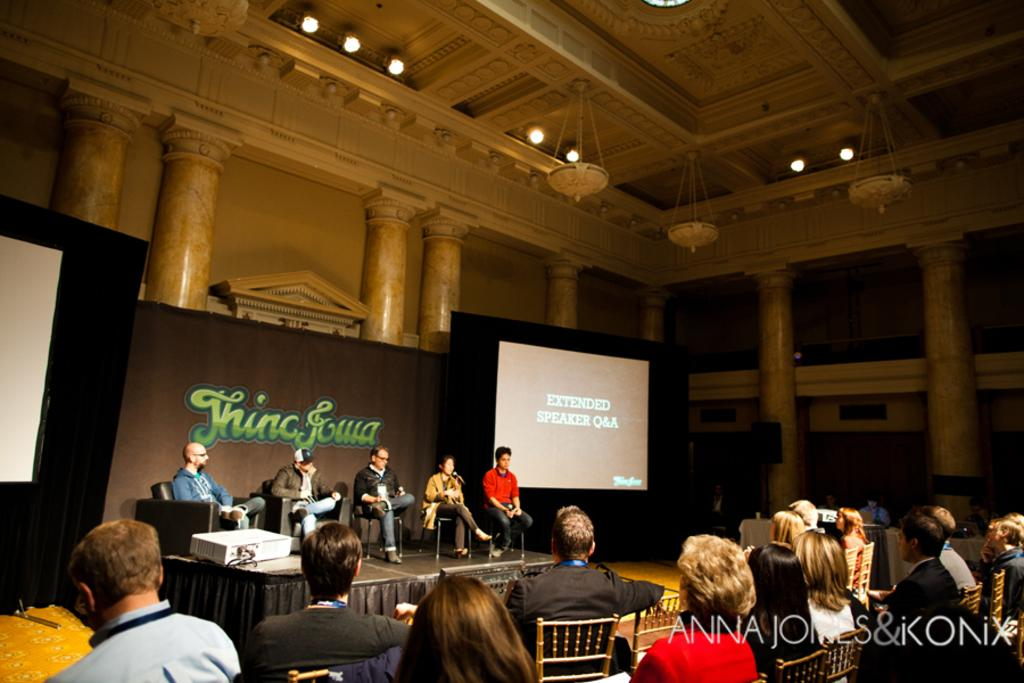What are the people in the image doing? The people in the image are sitting. What are the people sitting on in the image? There are chairs in the image. What can be seen in the background of the image? There is a screen and written text boards in the background of the image. What is visible at the top of the image? There are lights visible at the top of the image. What type of smell can be detected in the image? There is no information about smells in the image, so it cannot be determined. 